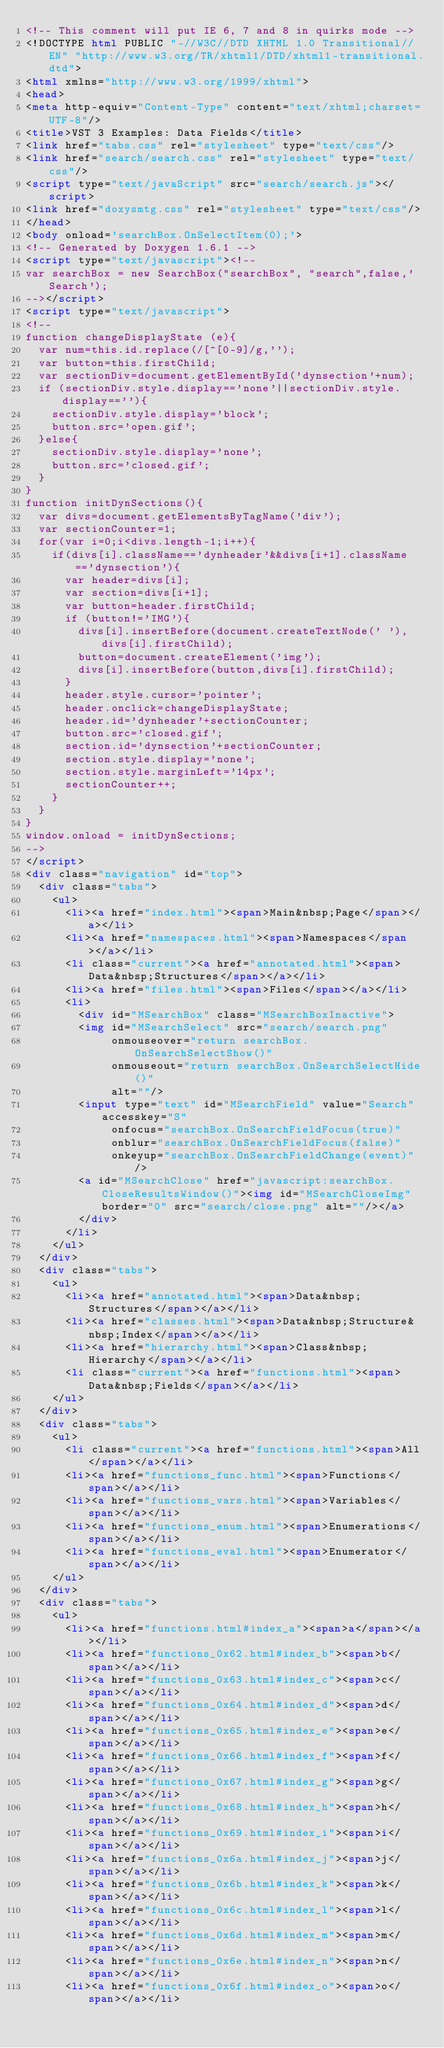<code> <loc_0><loc_0><loc_500><loc_500><_HTML_><!-- This comment will put IE 6, 7 and 8 in quirks mode -->
<!DOCTYPE html PUBLIC "-//W3C//DTD XHTML 1.0 Transitional//EN" "http://www.w3.org/TR/xhtml1/DTD/xhtml1-transitional.dtd">
<html xmlns="http://www.w3.org/1999/xhtml">
<head>
<meta http-equiv="Content-Type" content="text/xhtml;charset=UTF-8"/>
<title>VST 3 Examples: Data Fields</title>
<link href="tabs.css" rel="stylesheet" type="text/css"/>
<link href="search/search.css" rel="stylesheet" type="text/css"/>
<script type="text/javaScript" src="search/search.js"></script>
<link href="doxysmtg.css" rel="stylesheet" type="text/css"/>
</head>
<body onload='searchBox.OnSelectItem(0);'>
<!-- Generated by Doxygen 1.6.1 -->
<script type="text/javascript"><!--
var searchBox = new SearchBox("searchBox", "search",false,'Search');
--></script>
<script type="text/javascript">
<!--
function changeDisplayState (e){
  var num=this.id.replace(/[^[0-9]/g,'');
  var button=this.firstChild;
  var sectionDiv=document.getElementById('dynsection'+num);
  if (sectionDiv.style.display=='none'||sectionDiv.style.display==''){
    sectionDiv.style.display='block';
    button.src='open.gif';
  }else{
    sectionDiv.style.display='none';
    button.src='closed.gif';
  }
}
function initDynSections(){
  var divs=document.getElementsByTagName('div');
  var sectionCounter=1;
  for(var i=0;i<divs.length-1;i++){
    if(divs[i].className=='dynheader'&&divs[i+1].className=='dynsection'){
      var header=divs[i];
      var section=divs[i+1];
      var button=header.firstChild;
      if (button!='IMG'){
        divs[i].insertBefore(document.createTextNode(' '),divs[i].firstChild);
        button=document.createElement('img');
        divs[i].insertBefore(button,divs[i].firstChild);
      }
      header.style.cursor='pointer';
      header.onclick=changeDisplayState;
      header.id='dynheader'+sectionCounter;
      button.src='closed.gif';
      section.id='dynsection'+sectionCounter;
      section.style.display='none';
      section.style.marginLeft='14px';
      sectionCounter++;
    }
  }
}
window.onload = initDynSections;
-->
</script>
<div class="navigation" id="top">
  <div class="tabs">
    <ul>
      <li><a href="index.html"><span>Main&nbsp;Page</span></a></li>
      <li><a href="namespaces.html"><span>Namespaces</span></a></li>
      <li class="current"><a href="annotated.html"><span>Data&nbsp;Structures</span></a></li>
      <li><a href="files.html"><span>Files</span></a></li>
      <li>
        <div id="MSearchBox" class="MSearchBoxInactive">
        <img id="MSearchSelect" src="search/search.png"
             onmouseover="return searchBox.OnSearchSelectShow()"
             onmouseout="return searchBox.OnSearchSelectHide()"
             alt=""/>
        <input type="text" id="MSearchField" value="Search" accesskey="S"
             onfocus="searchBox.OnSearchFieldFocus(true)" 
             onblur="searchBox.OnSearchFieldFocus(false)" 
             onkeyup="searchBox.OnSearchFieldChange(event)"/>
        <a id="MSearchClose" href="javascript:searchBox.CloseResultsWindow()"><img id="MSearchCloseImg" border="0" src="search/close.png" alt=""/></a>
        </div>
      </li>
    </ul>
  </div>
  <div class="tabs">
    <ul>
      <li><a href="annotated.html"><span>Data&nbsp;Structures</span></a></li>
      <li><a href="classes.html"><span>Data&nbsp;Structure&nbsp;Index</span></a></li>
      <li><a href="hierarchy.html"><span>Class&nbsp;Hierarchy</span></a></li>
      <li class="current"><a href="functions.html"><span>Data&nbsp;Fields</span></a></li>
    </ul>
  </div>
  <div class="tabs">
    <ul>
      <li class="current"><a href="functions.html"><span>All</span></a></li>
      <li><a href="functions_func.html"><span>Functions</span></a></li>
      <li><a href="functions_vars.html"><span>Variables</span></a></li>
      <li><a href="functions_enum.html"><span>Enumerations</span></a></li>
      <li><a href="functions_eval.html"><span>Enumerator</span></a></li>
    </ul>
  </div>
  <div class="tabs">
    <ul>
      <li><a href="functions.html#index_a"><span>a</span></a></li>
      <li><a href="functions_0x62.html#index_b"><span>b</span></a></li>
      <li><a href="functions_0x63.html#index_c"><span>c</span></a></li>
      <li><a href="functions_0x64.html#index_d"><span>d</span></a></li>
      <li><a href="functions_0x65.html#index_e"><span>e</span></a></li>
      <li><a href="functions_0x66.html#index_f"><span>f</span></a></li>
      <li><a href="functions_0x67.html#index_g"><span>g</span></a></li>
      <li><a href="functions_0x68.html#index_h"><span>h</span></a></li>
      <li><a href="functions_0x69.html#index_i"><span>i</span></a></li>
      <li><a href="functions_0x6a.html#index_j"><span>j</span></a></li>
      <li><a href="functions_0x6b.html#index_k"><span>k</span></a></li>
      <li><a href="functions_0x6c.html#index_l"><span>l</span></a></li>
      <li><a href="functions_0x6d.html#index_m"><span>m</span></a></li>
      <li><a href="functions_0x6e.html#index_n"><span>n</span></a></li>
      <li><a href="functions_0x6f.html#index_o"><span>o</span></a></li></code> 